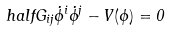Convert formula to latex. <formula><loc_0><loc_0><loc_500><loc_500>\ h a l f G _ { i j } \dot { \phi } ^ { i } \dot { \phi } ^ { j } - V ( \phi ) = 0</formula> 